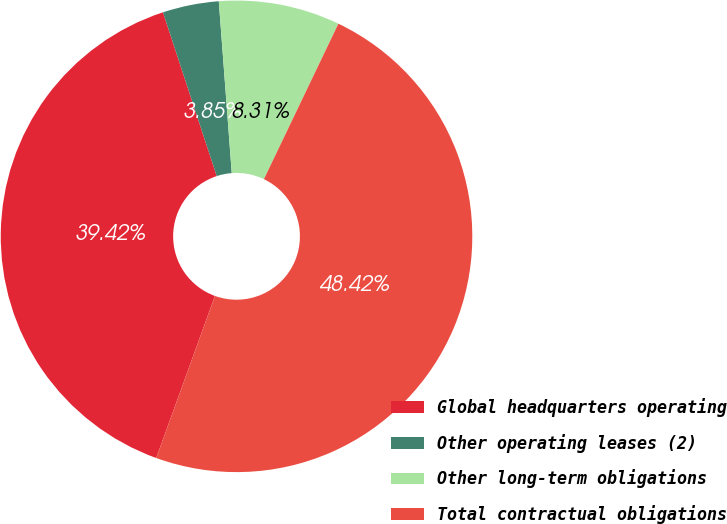Convert chart to OTSL. <chart><loc_0><loc_0><loc_500><loc_500><pie_chart><fcel>Global headquarters operating<fcel>Other operating leases (2)<fcel>Other long-term obligations<fcel>Total contractual obligations<nl><fcel>39.42%<fcel>3.85%<fcel>8.31%<fcel>48.42%<nl></chart> 